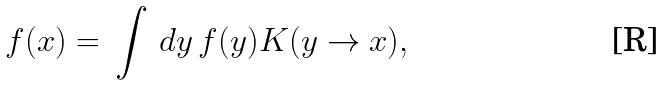Convert formula to latex. <formula><loc_0><loc_0><loc_500><loc_500>f ( x ) = \, \int \, d y \, f ( y ) K ( y \rightarrow x ) ,</formula> 